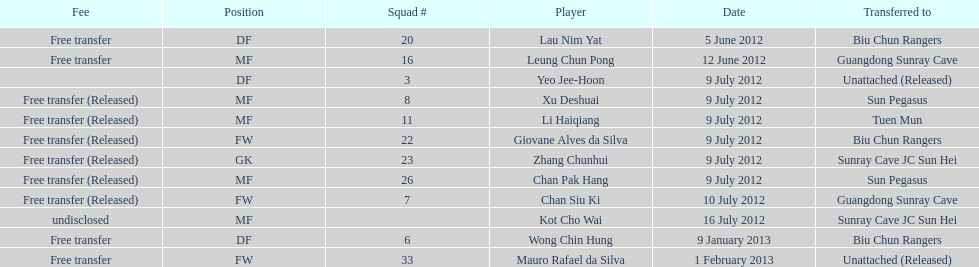Which team did lau nim yat play for after he was transferred? Biu Chun Rangers. 